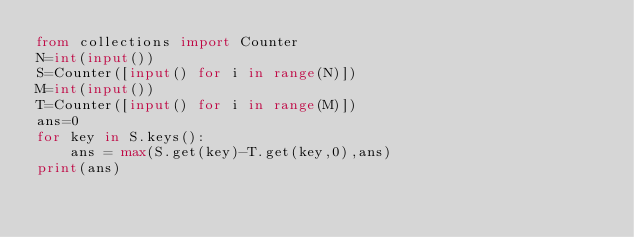<code> <loc_0><loc_0><loc_500><loc_500><_Python_>from collections import Counter
N=int(input())
S=Counter([input() for i in range(N)])
M=int(input())
T=Counter([input() for i in range(M)])
ans=0
for key in S.keys():
    ans = max(S.get(key)-T.get(key,0),ans)
print(ans)</code> 